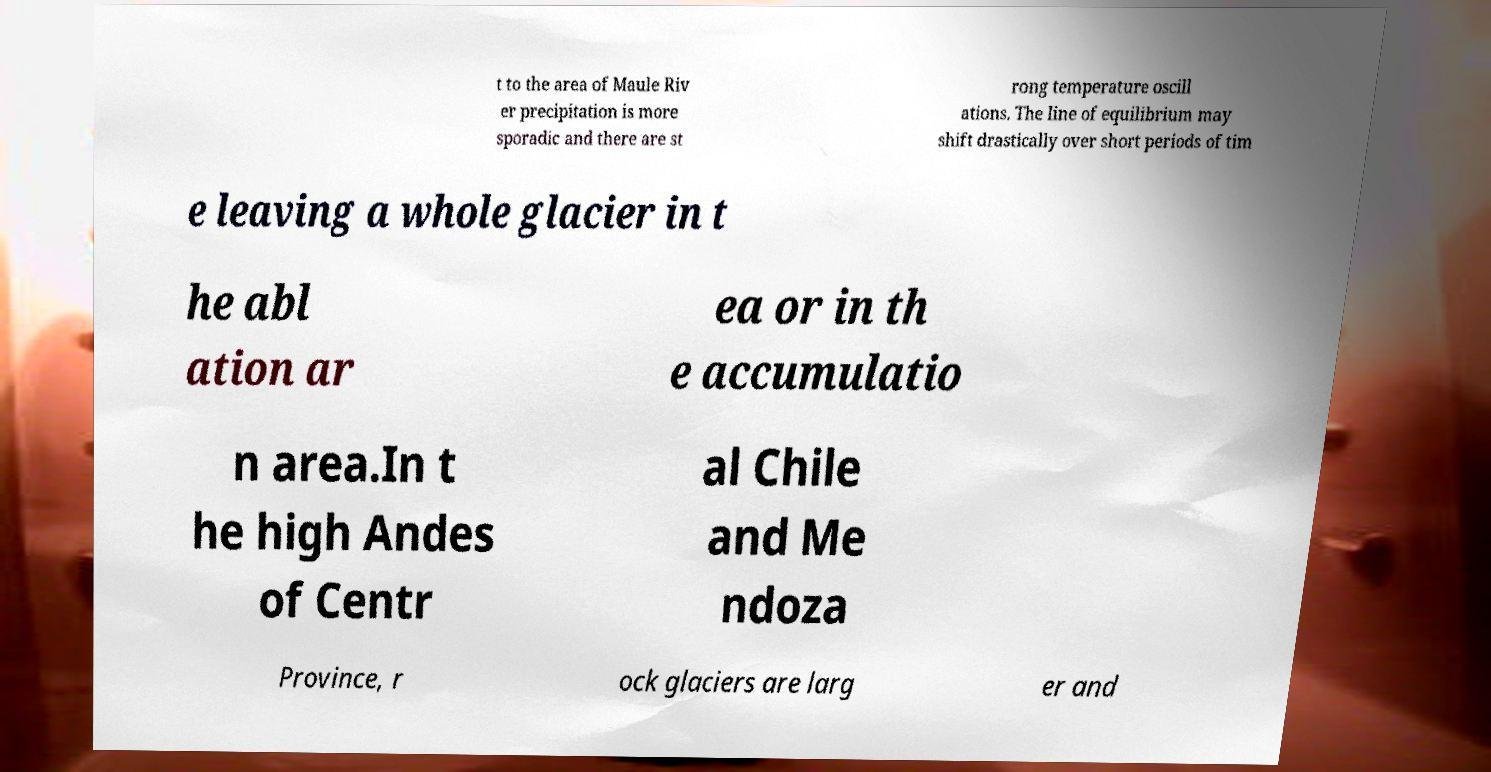Please read and relay the text visible in this image. What does it say? t to the area of Maule Riv er precipitation is more sporadic and there are st rong temperature oscill ations. The line of equilibrium may shift drastically over short periods of tim e leaving a whole glacier in t he abl ation ar ea or in th e accumulatio n area.In t he high Andes of Centr al Chile and Me ndoza Province, r ock glaciers are larg er and 